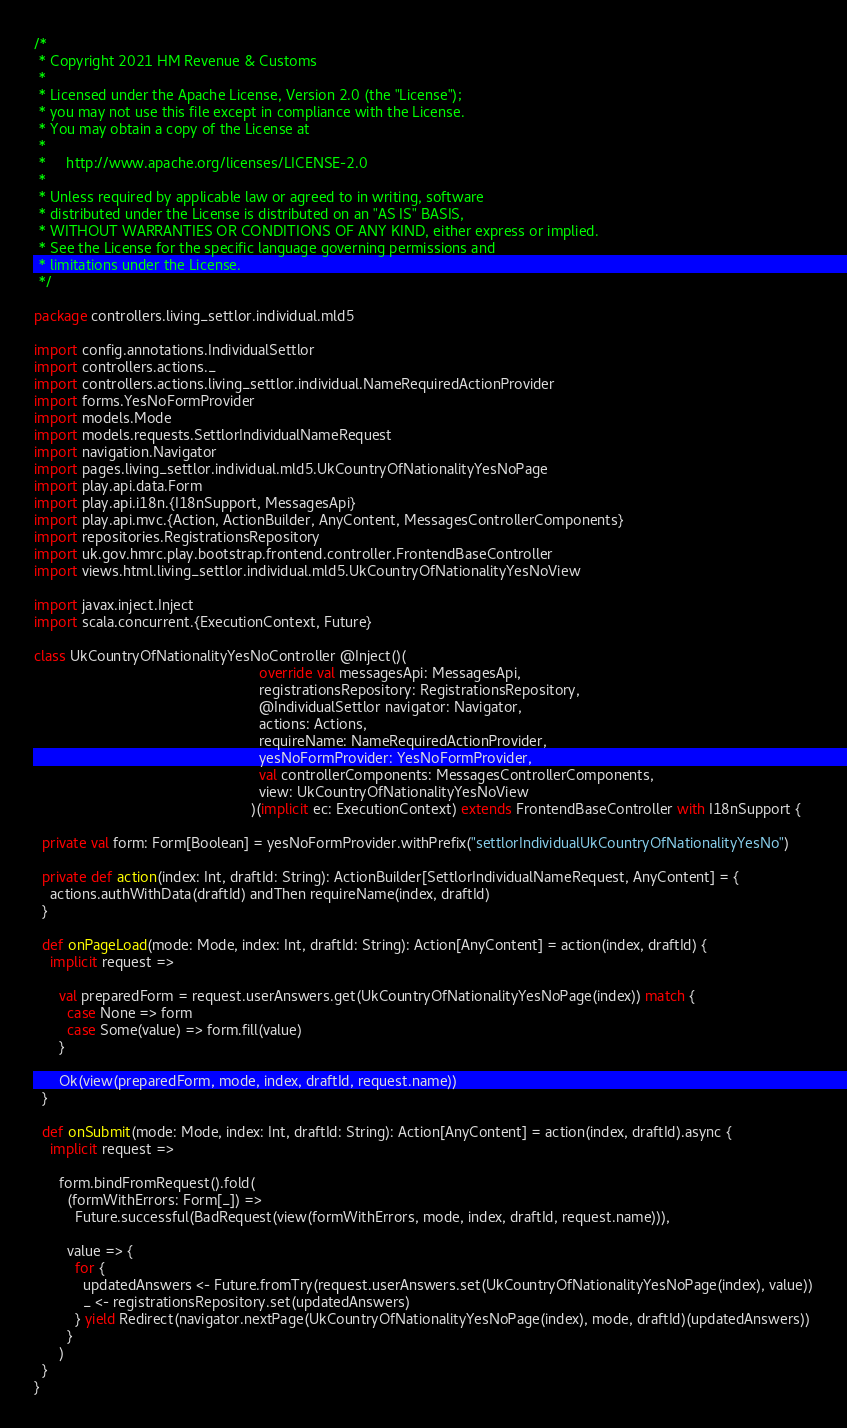Convert code to text. <code><loc_0><loc_0><loc_500><loc_500><_Scala_>/*
 * Copyright 2021 HM Revenue & Customs
 *
 * Licensed under the Apache License, Version 2.0 (the "License");
 * you may not use this file except in compliance with the License.
 * You may obtain a copy of the License at
 *
 *     http://www.apache.org/licenses/LICENSE-2.0
 *
 * Unless required by applicable law or agreed to in writing, software
 * distributed under the License is distributed on an "AS IS" BASIS,
 * WITHOUT WARRANTIES OR CONDITIONS OF ANY KIND, either express or implied.
 * See the License for the specific language governing permissions and
 * limitations under the License.
 */

package controllers.living_settlor.individual.mld5

import config.annotations.IndividualSettlor
import controllers.actions._
import controllers.actions.living_settlor.individual.NameRequiredActionProvider
import forms.YesNoFormProvider
import models.Mode
import models.requests.SettlorIndividualNameRequest
import navigation.Navigator
import pages.living_settlor.individual.mld5.UkCountryOfNationalityYesNoPage
import play.api.data.Form
import play.api.i18n.{I18nSupport, MessagesApi}
import play.api.mvc.{Action, ActionBuilder, AnyContent, MessagesControllerComponents}
import repositories.RegistrationsRepository
import uk.gov.hmrc.play.bootstrap.frontend.controller.FrontendBaseController
import views.html.living_settlor.individual.mld5.UkCountryOfNationalityYesNoView

import javax.inject.Inject
import scala.concurrent.{ExecutionContext, Future}

class UkCountryOfNationalityYesNoController @Inject()(
                                                       override val messagesApi: MessagesApi,
                                                       registrationsRepository: RegistrationsRepository,
                                                       @IndividualSettlor navigator: Navigator,
                                                       actions: Actions,
                                                       requireName: NameRequiredActionProvider,
                                                       yesNoFormProvider: YesNoFormProvider,
                                                       val controllerComponents: MessagesControllerComponents,
                                                       view: UkCountryOfNationalityYesNoView
                                                     )(implicit ec: ExecutionContext) extends FrontendBaseController with I18nSupport {

  private val form: Form[Boolean] = yesNoFormProvider.withPrefix("settlorIndividualUkCountryOfNationalityYesNo")

  private def action(index: Int, draftId: String): ActionBuilder[SettlorIndividualNameRequest, AnyContent] = {
    actions.authWithData(draftId) andThen requireName(index, draftId)
  }

  def onPageLoad(mode: Mode, index: Int, draftId: String): Action[AnyContent] = action(index, draftId) {
    implicit request =>

      val preparedForm = request.userAnswers.get(UkCountryOfNationalityYesNoPage(index)) match {
        case None => form
        case Some(value) => form.fill(value)
      }

      Ok(view(preparedForm, mode, index, draftId, request.name))
  }

  def onSubmit(mode: Mode, index: Int, draftId: String): Action[AnyContent] = action(index, draftId).async {
    implicit request =>

      form.bindFromRequest().fold(
        (formWithErrors: Form[_]) =>
          Future.successful(BadRequest(view(formWithErrors, mode, index, draftId, request.name))),

        value => {
          for {
            updatedAnswers <- Future.fromTry(request.userAnswers.set(UkCountryOfNationalityYesNoPage(index), value))
            _ <- registrationsRepository.set(updatedAnswers)
          } yield Redirect(navigator.nextPage(UkCountryOfNationalityYesNoPage(index), mode, draftId)(updatedAnswers))
        }
      )
  }
}
</code> 